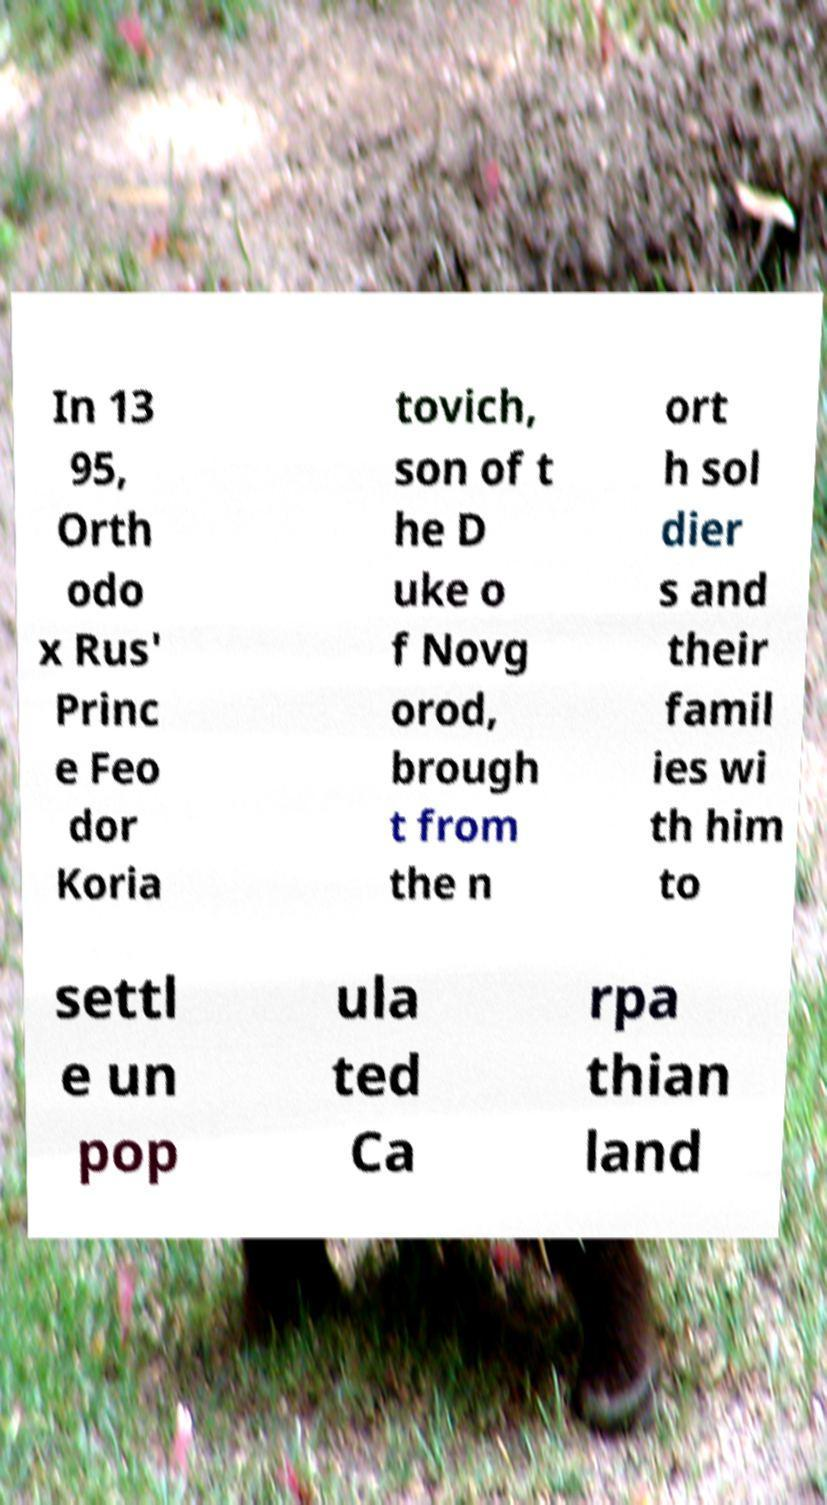There's text embedded in this image that I need extracted. Can you transcribe it verbatim? In 13 95, Orth odo x Rus' Princ e Feo dor Koria tovich, son of t he D uke o f Novg orod, brough t from the n ort h sol dier s and their famil ies wi th him to settl e un pop ula ted Ca rpa thian land 